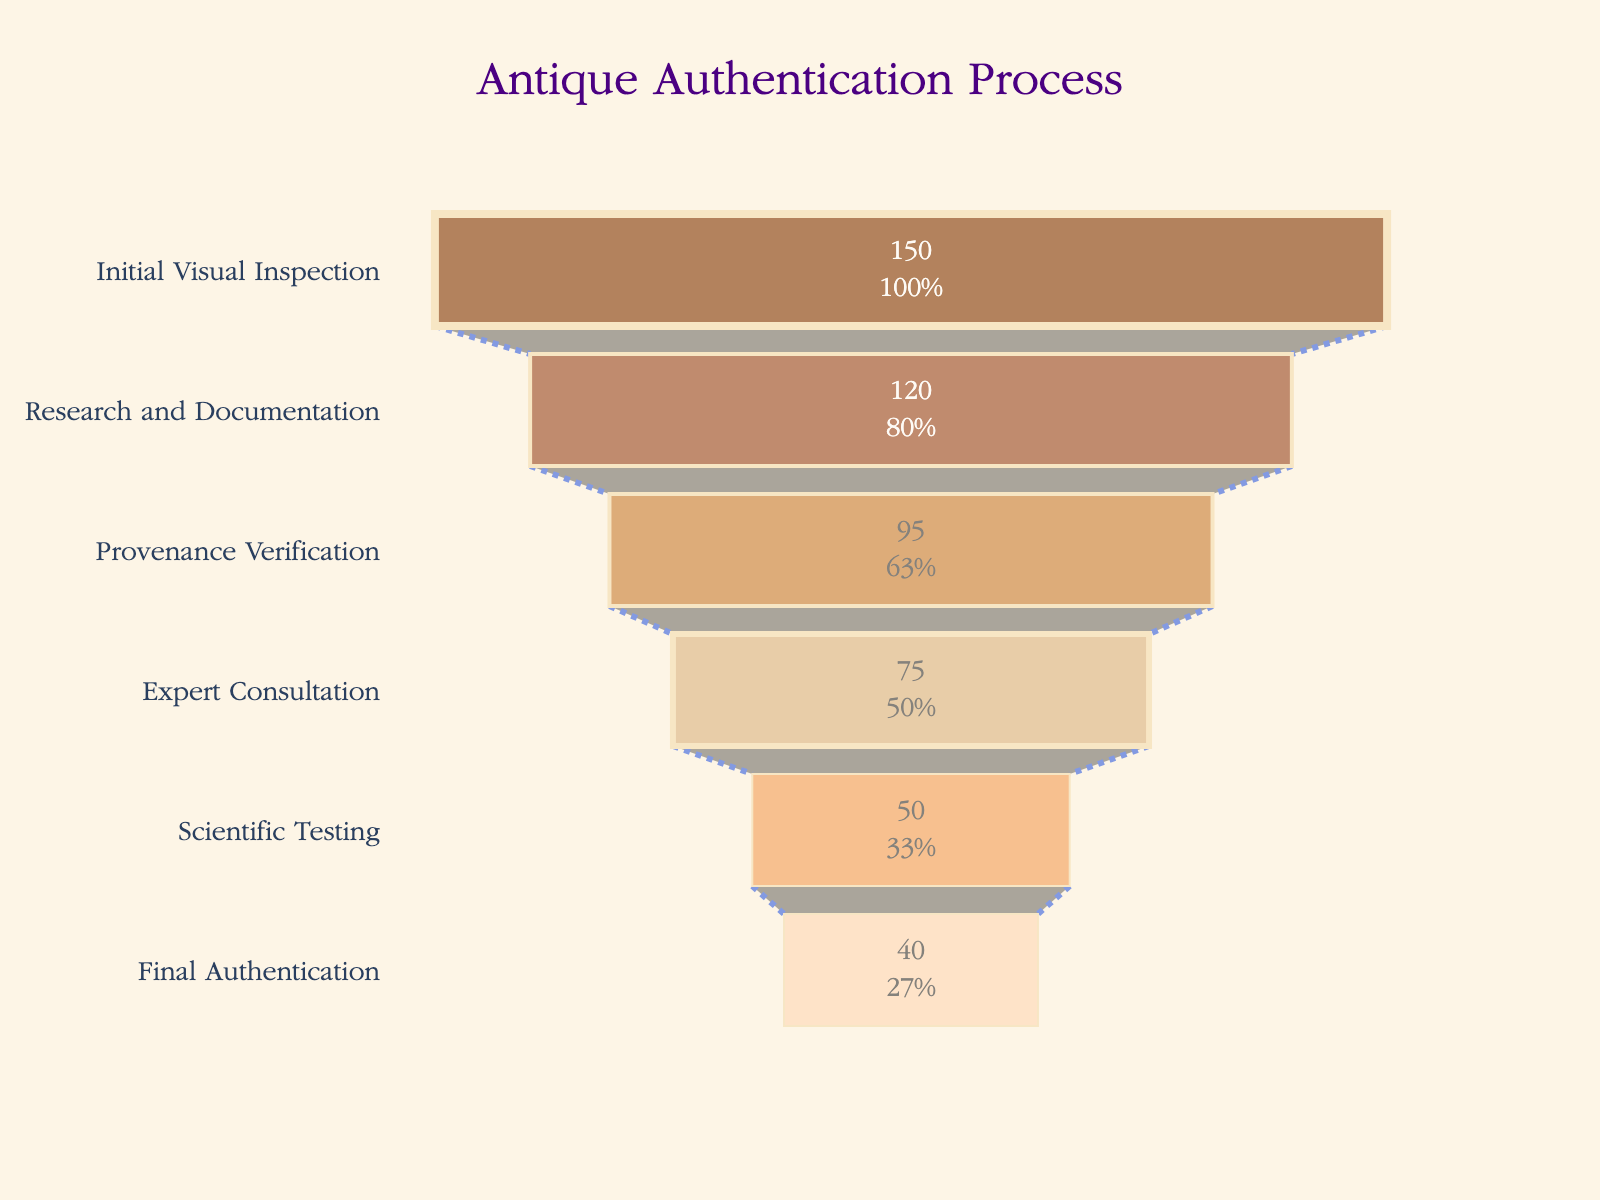What is the title of the plot? The title of the plot is typically at the top center of the chart. By looking at this location, you will find the title "Antique Authentication Process".
Answer: Antique Authentication Process How many stages are there in the antique authentication process? By counting the number of distinct segments or labels on the Y-axis, we find there are six stages, each representing a step in the process.
Answer: Six Which stage has the highest number of items? The stage with the largest value on the X-axis represents the highest number of items. In this chart, "Initial Visual Inspection" has 150 items, the highest among all stages.
Answer: Initial Visual Inspection How many items were reduced from the 'Research and Documentation' stage to the 'Provenance Verification' stage? To determine the reduction, subtract the number of items at the 'Provenance Verification' stage (95) from the 'Research and Documentation' stage (120). This results in a reduction of 25 items.
Answer: 25 Which stage has the least number of items, and how many items does it have? The smallest value on the X-axis represents the stage with the least number of items. "Final Authentication" has the least, with 40 items.
Answer: Final Authentication, 40 What percentage of items pass from 'Initial Visual Inspection' to 'Research and Documentation'? To calculate this, divide the number of items in 'Research and Documentation' (120) by the number of items in 'Initial Visual Inspection' (150) and multiply by 100. The calculation is (120 / 150) * 100 = 80%.
Answer: 80% How does the number of items change from 'Scientific Testing' to 'Final Authentication'? Subtract the number of items in 'Final Authentication' (40) from 'Scientific Testing' (50). This shows a reduction of 10 items.
Answer: Reduced by 10 What is the stage before the 'Scientific Testing' stage, and how many items are in that stage? By looking at the Y-axis labels, we see the stage before 'Scientific Testing' is 'Expert Consultation', which has 75 items.
Answer: Expert Consultation, 75 Which stage shows the greatest percentage decrease in the number of items compared to its previous stage? For each stage, calculate the percentage decrease from the previous stage and compare. The largest decrease occurs from 'Scientific Testing' (50) to 'Final Authentication' (40): ((50 - 40) / 50) * 100 = 20%.
Answer: Scientific Testing to Final Authentication, 20% What color is used for the 'Research and Documentation' stage? The color for each stage is visually distinct. The 'Research and Documentation' stage uses a burnt orange color, which can be described as "#A0522D" in web color terms.
Answer: Burnt orange 